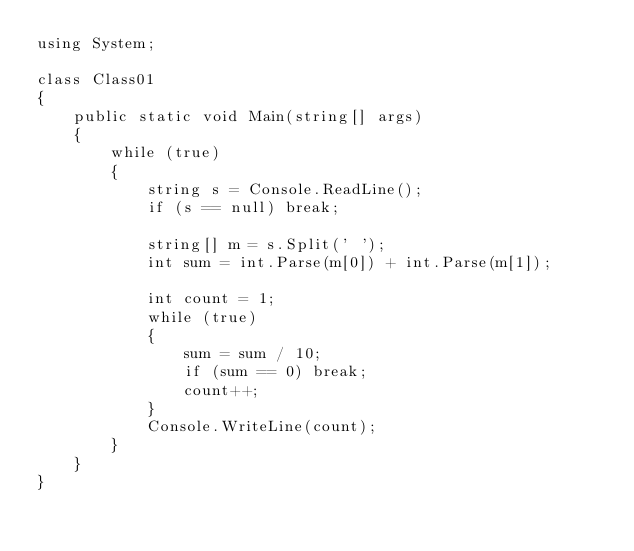Convert code to text. <code><loc_0><loc_0><loc_500><loc_500><_C#_>using System;

class Class01
{
    public static void Main(string[] args)
    {
        while (true)
        {
            string s = Console.ReadLine();
            if (s == null) break;

            string[] m = s.Split(' ');
            int sum = int.Parse(m[0]) + int.Parse(m[1]);

            int count = 1;
            while (true)
            {
                sum = sum / 10;
                if (sum == 0) break;
                count++;
            }
            Console.WriteLine(count);
        }
    }
}</code> 